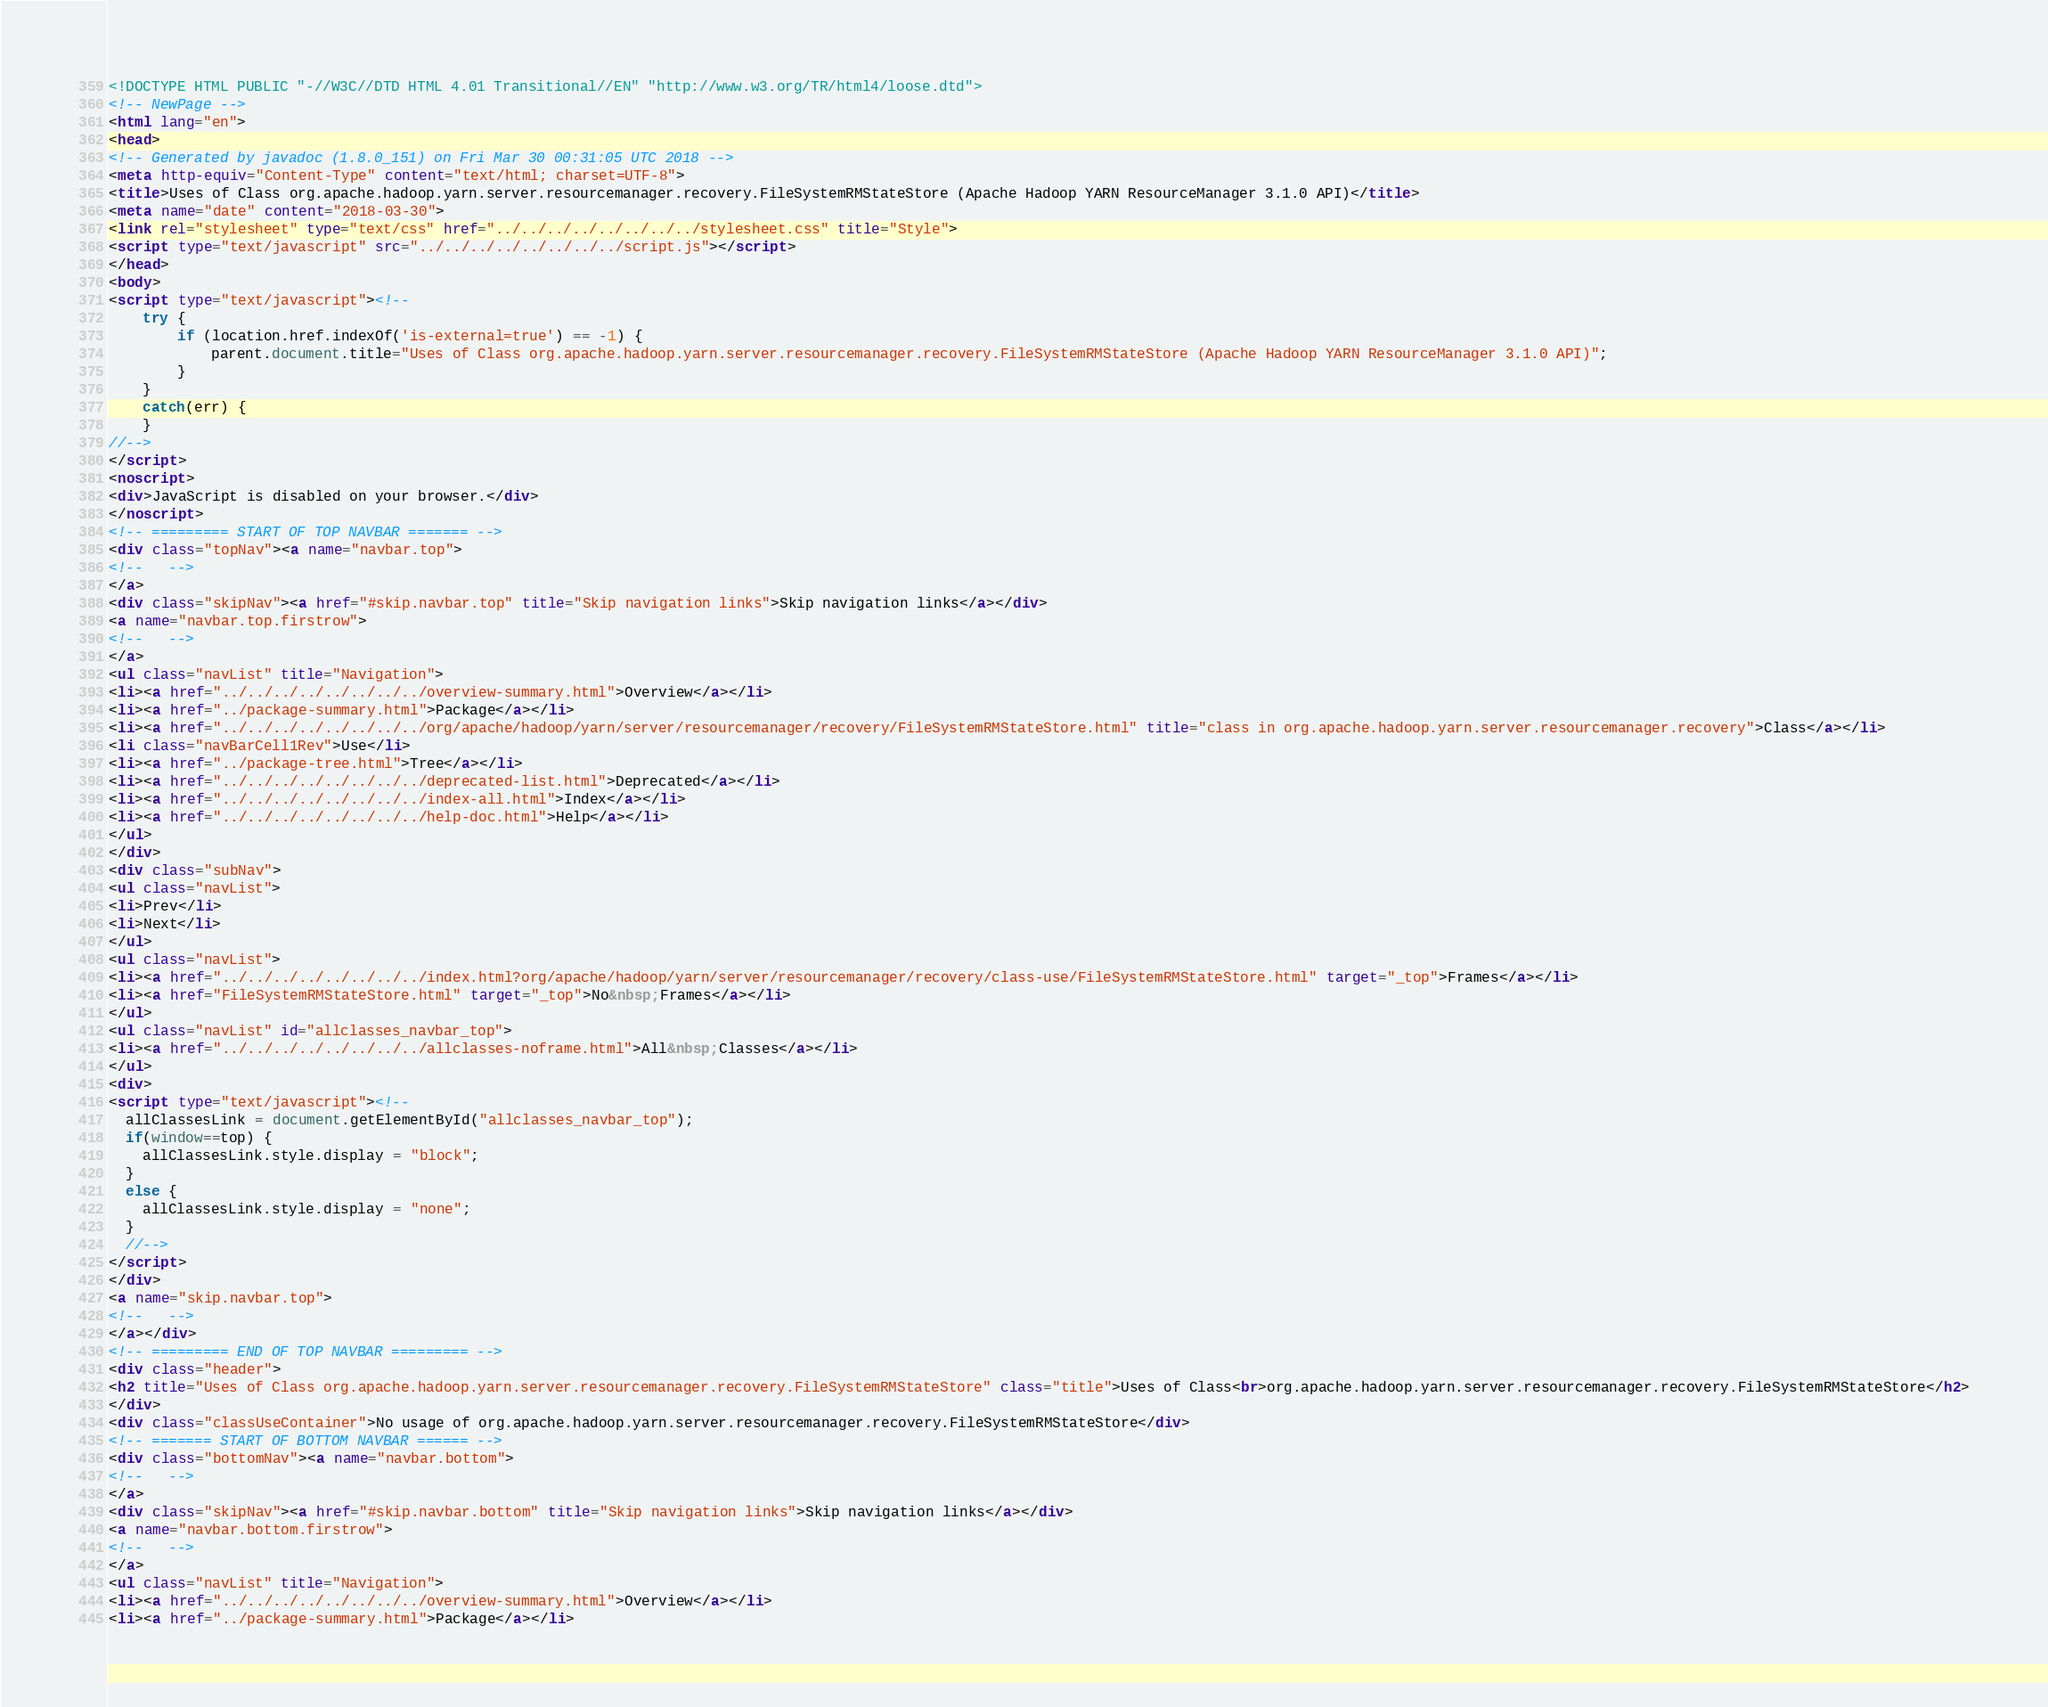<code> <loc_0><loc_0><loc_500><loc_500><_HTML_><!DOCTYPE HTML PUBLIC "-//W3C//DTD HTML 4.01 Transitional//EN" "http://www.w3.org/TR/html4/loose.dtd">
<!-- NewPage -->
<html lang="en">
<head>
<!-- Generated by javadoc (1.8.0_151) on Fri Mar 30 00:31:05 UTC 2018 -->
<meta http-equiv="Content-Type" content="text/html; charset=UTF-8">
<title>Uses of Class org.apache.hadoop.yarn.server.resourcemanager.recovery.FileSystemRMStateStore (Apache Hadoop YARN ResourceManager 3.1.0 API)</title>
<meta name="date" content="2018-03-30">
<link rel="stylesheet" type="text/css" href="../../../../../../../../stylesheet.css" title="Style">
<script type="text/javascript" src="../../../../../../../../script.js"></script>
</head>
<body>
<script type="text/javascript"><!--
    try {
        if (location.href.indexOf('is-external=true') == -1) {
            parent.document.title="Uses of Class org.apache.hadoop.yarn.server.resourcemanager.recovery.FileSystemRMStateStore (Apache Hadoop YARN ResourceManager 3.1.0 API)";
        }
    }
    catch(err) {
    }
//-->
</script>
<noscript>
<div>JavaScript is disabled on your browser.</div>
</noscript>
<!-- ========= START OF TOP NAVBAR ======= -->
<div class="topNav"><a name="navbar.top">
<!--   -->
</a>
<div class="skipNav"><a href="#skip.navbar.top" title="Skip navigation links">Skip navigation links</a></div>
<a name="navbar.top.firstrow">
<!--   -->
</a>
<ul class="navList" title="Navigation">
<li><a href="../../../../../../../../overview-summary.html">Overview</a></li>
<li><a href="../package-summary.html">Package</a></li>
<li><a href="../../../../../../../../org/apache/hadoop/yarn/server/resourcemanager/recovery/FileSystemRMStateStore.html" title="class in org.apache.hadoop.yarn.server.resourcemanager.recovery">Class</a></li>
<li class="navBarCell1Rev">Use</li>
<li><a href="../package-tree.html">Tree</a></li>
<li><a href="../../../../../../../../deprecated-list.html">Deprecated</a></li>
<li><a href="../../../../../../../../index-all.html">Index</a></li>
<li><a href="../../../../../../../../help-doc.html">Help</a></li>
</ul>
</div>
<div class="subNav">
<ul class="navList">
<li>Prev</li>
<li>Next</li>
</ul>
<ul class="navList">
<li><a href="../../../../../../../../index.html?org/apache/hadoop/yarn/server/resourcemanager/recovery/class-use/FileSystemRMStateStore.html" target="_top">Frames</a></li>
<li><a href="FileSystemRMStateStore.html" target="_top">No&nbsp;Frames</a></li>
</ul>
<ul class="navList" id="allclasses_navbar_top">
<li><a href="../../../../../../../../allclasses-noframe.html">All&nbsp;Classes</a></li>
</ul>
<div>
<script type="text/javascript"><!--
  allClassesLink = document.getElementById("allclasses_navbar_top");
  if(window==top) {
    allClassesLink.style.display = "block";
  }
  else {
    allClassesLink.style.display = "none";
  }
  //-->
</script>
</div>
<a name="skip.navbar.top">
<!--   -->
</a></div>
<!-- ========= END OF TOP NAVBAR ========= -->
<div class="header">
<h2 title="Uses of Class org.apache.hadoop.yarn.server.resourcemanager.recovery.FileSystemRMStateStore" class="title">Uses of Class<br>org.apache.hadoop.yarn.server.resourcemanager.recovery.FileSystemRMStateStore</h2>
</div>
<div class="classUseContainer">No usage of org.apache.hadoop.yarn.server.resourcemanager.recovery.FileSystemRMStateStore</div>
<!-- ======= START OF BOTTOM NAVBAR ====== -->
<div class="bottomNav"><a name="navbar.bottom">
<!--   -->
</a>
<div class="skipNav"><a href="#skip.navbar.bottom" title="Skip navigation links">Skip navigation links</a></div>
<a name="navbar.bottom.firstrow">
<!--   -->
</a>
<ul class="navList" title="Navigation">
<li><a href="../../../../../../../../overview-summary.html">Overview</a></li>
<li><a href="../package-summary.html">Package</a></li></code> 